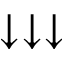<formula> <loc_0><loc_0><loc_500><loc_500>\downarrow \downarrow \downarrow</formula> 